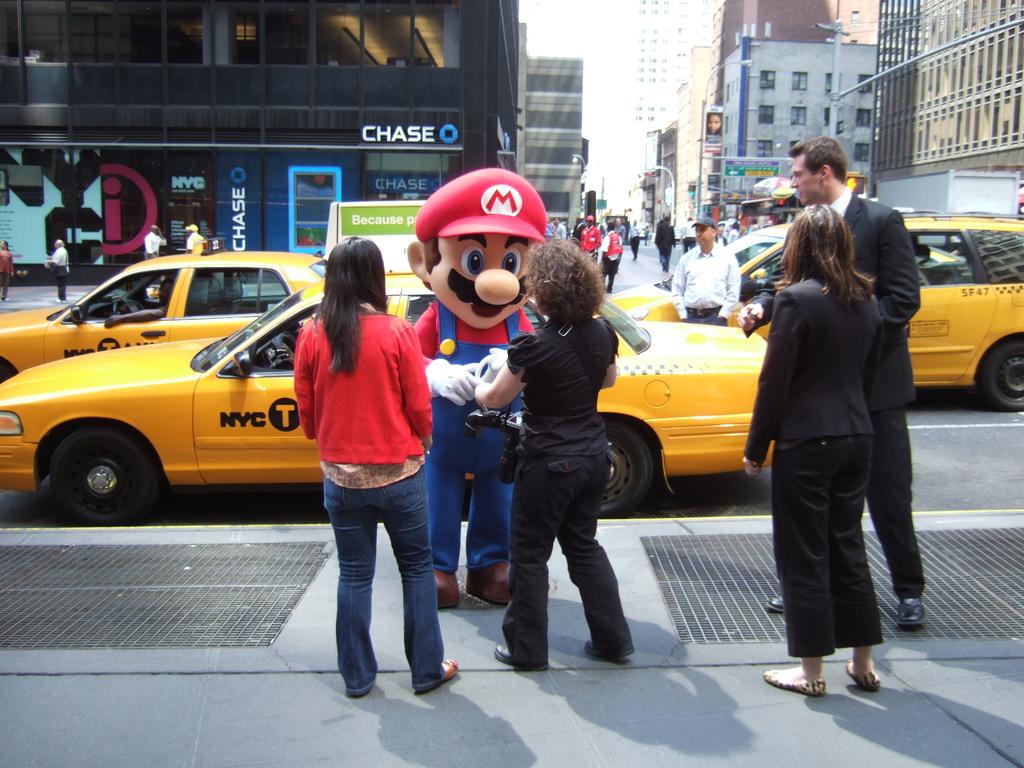What city is the taxi servicing?
Ensure brevity in your answer.  Nyc. Is that a bank across the street?
Keep it short and to the point. Yes. 